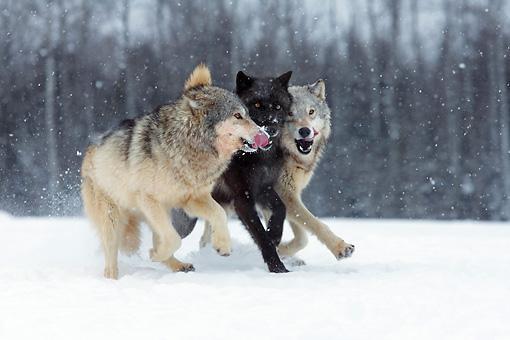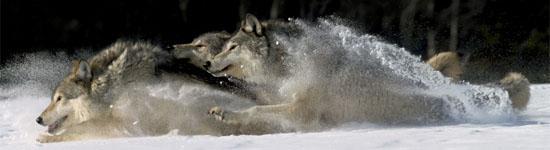The first image is the image on the left, the second image is the image on the right. Analyze the images presented: Is the assertion "There is at least one wolf that is completely black." valid? Answer yes or no. Yes. The first image is the image on the left, the second image is the image on the right. Considering the images on both sides, is "An image shows exactly three wolves, including one black one, running in a rightward direction." valid? Answer yes or no. Yes. 